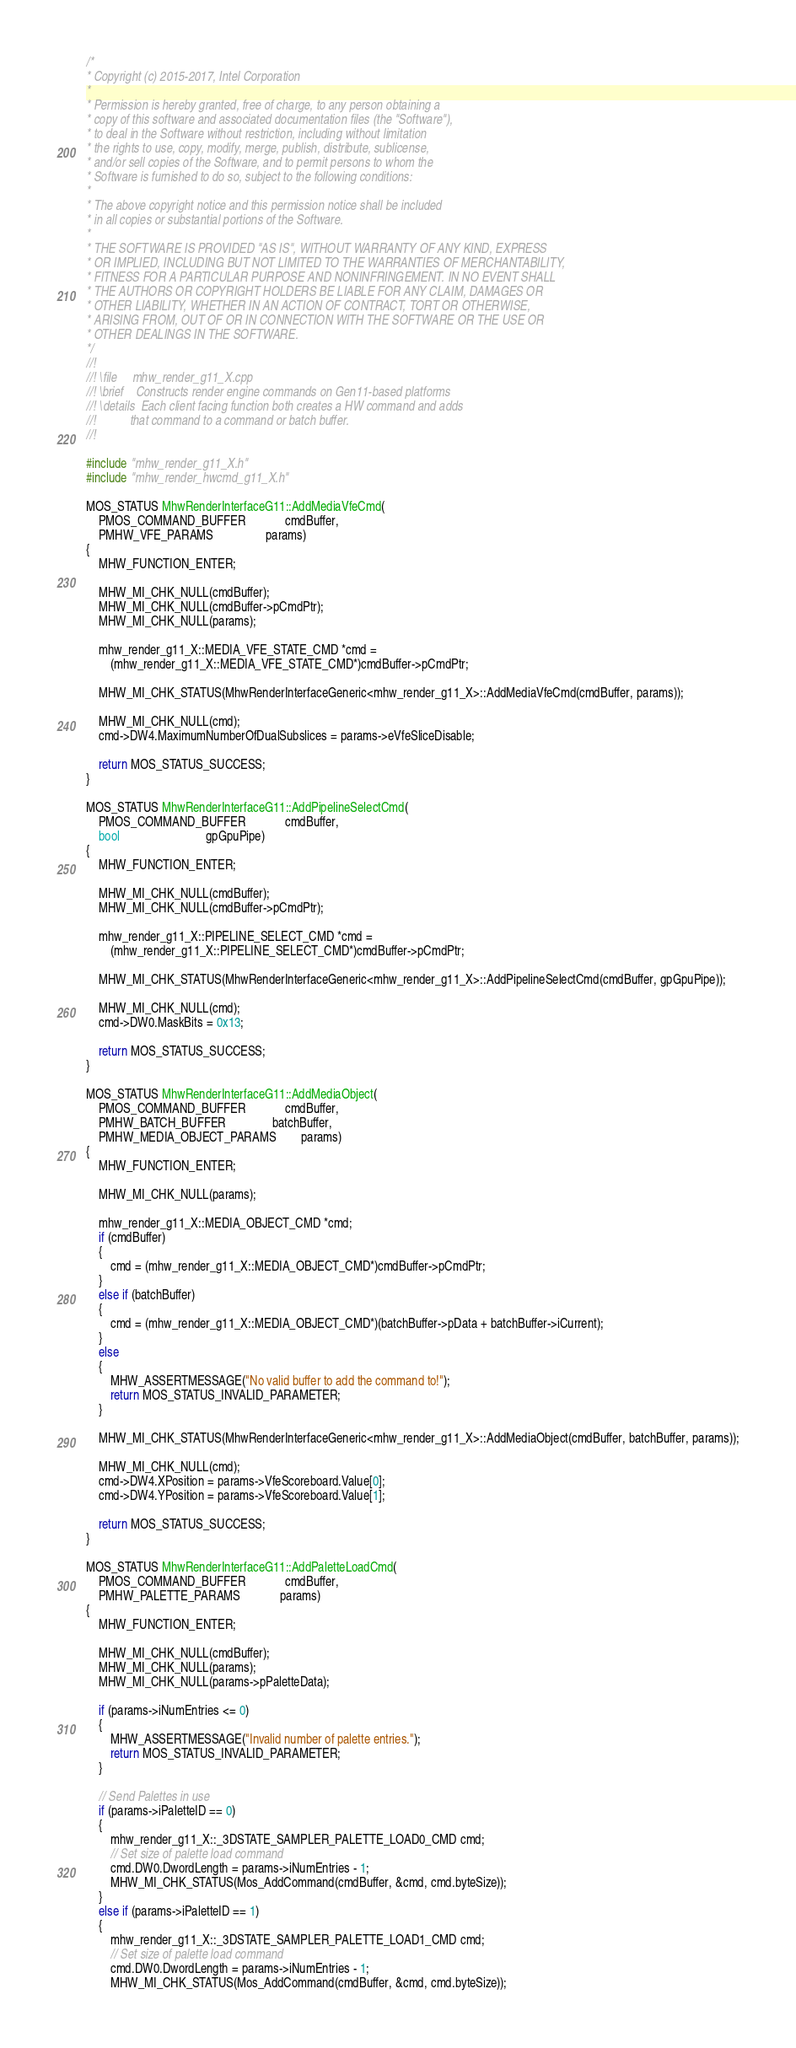<code> <loc_0><loc_0><loc_500><loc_500><_C++_>/*
* Copyright (c) 2015-2017, Intel Corporation
*
* Permission is hereby granted, free of charge, to any person obtaining a
* copy of this software and associated documentation files (the "Software"),
* to deal in the Software without restriction, including without limitation
* the rights to use, copy, modify, merge, publish, distribute, sublicense,
* and/or sell copies of the Software, and to permit persons to whom the
* Software is furnished to do so, subject to the following conditions:
*
* The above copyright notice and this permission notice shall be included
* in all copies or substantial portions of the Software.
*
* THE SOFTWARE IS PROVIDED "AS IS", WITHOUT WARRANTY OF ANY KIND, EXPRESS
* OR IMPLIED, INCLUDING BUT NOT LIMITED TO THE WARRANTIES OF MERCHANTABILITY,
* FITNESS FOR A PARTICULAR PURPOSE AND NONINFRINGEMENT. IN NO EVENT SHALL
* THE AUTHORS OR COPYRIGHT HOLDERS BE LIABLE FOR ANY CLAIM, DAMAGES OR
* OTHER LIABILITY, WHETHER IN AN ACTION OF CONTRACT, TORT OR OTHERWISE,
* ARISING FROM, OUT OF OR IN CONNECTION WITH THE SOFTWARE OR THE USE OR
* OTHER DEALINGS IN THE SOFTWARE.
*/
//!
//! \file     mhw_render_g11_X.cpp
//! \brief    Constructs render engine commands on Gen11-based platforms
//! \details  Each client facing function both creates a HW command and adds
//!           that command to a command or batch buffer.
//!

#include "mhw_render_g11_X.h"
#include "mhw_render_hwcmd_g11_X.h"

MOS_STATUS MhwRenderInterfaceG11::AddMediaVfeCmd(
    PMOS_COMMAND_BUFFER             cmdBuffer,
    PMHW_VFE_PARAMS                 params)
{
    MHW_FUNCTION_ENTER;

    MHW_MI_CHK_NULL(cmdBuffer);
    MHW_MI_CHK_NULL(cmdBuffer->pCmdPtr);
    MHW_MI_CHK_NULL(params);

    mhw_render_g11_X::MEDIA_VFE_STATE_CMD *cmd =
        (mhw_render_g11_X::MEDIA_VFE_STATE_CMD*)cmdBuffer->pCmdPtr;
    
    MHW_MI_CHK_STATUS(MhwRenderInterfaceGeneric<mhw_render_g11_X>::AddMediaVfeCmd(cmdBuffer, params));

    MHW_MI_CHK_NULL(cmd);
    cmd->DW4.MaximumNumberOfDualSubslices = params->eVfeSliceDisable;

    return MOS_STATUS_SUCCESS;
}

MOS_STATUS MhwRenderInterfaceG11::AddPipelineSelectCmd(
    PMOS_COMMAND_BUFFER             cmdBuffer,
    bool                            gpGpuPipe)
{
    MHW_FUNCTION_ENTER;

    MHW_MI_CHK_NULL(cmdBuffer);
    MHW_MI_CHK_NULL(cmdBuffer->pCmdPtr);

    mhw_render_g11_X::PIPELINE_SELECT_CMD *cmd =
        (mhw_render_g11_X::PIPELINE_SELECT_CMD*)cmdBuffer->pCmdPtr;

    MHW_MI_CHK_STATUS(MhwRenderInterfaceGeneric<mhw_render_g11_X>::AddPipelineSelectCmd(cmdBuffer, gpGpuPipe));

    MHW_MI_CHK_NULL(cmd);
    cmd->DW0.MaskBits = 0x13;

    return MOS_STATUS_SUCCESS;
}

MOS_STATUS MhwRenderInterfaceG11::AddMediaObject(
    PMOS_COMMAND_BUFFER             cmdBuffer,
    PMHW_BATCH_BUFFER               batchBuffer,
    PMHW_MEDIA_OBJECT_PARAMS        params)
{
    MHW_FUNCTION_ENTER;

    MHW_MI_CHK_NULL(params);

    mhw_render_g11_X::MEDIA_OBJECT_CMD *cmd;
    if (cmdBuffer)
    {
        cmd = (mhw_render_g11_X::MEDIA_OBJECT_CMD*)cmdBuffer->pCmdPtr;
    }
    else if (batchBuffer)
    {
        cmd = (mhw_render_g11_X::MEDIA_OBJECT_CMD*)(batchBuffer->pData + batchBuffer->iCurrent);
    }
    else
    {
        MHW_ASSERTMESSAGE("No valid buffer to add the command to!");
        return MOS_STATUS_INVALID_PARAMETER;
    }

    MHW_MI_CHK_STATUS(MhwRenderInterfaceGeneric<mhw_render_g11_X>::AddMediaObject(cmdBuffer, batchBuffer, params));

    MHW_MI_CHK_NULL(cmd);
    cmd->DW4.XPosition = params->VfeScoreboard.Value[0];
    cmd->DW4.YPosition = params->VfeScoreboard.Value[1];

    return MOS_STATUS_SUCCESS;
}

MOS_STATUS MhwRenderInterfaceG11::AddPaletteLoadCmd(
    PMOS_COMMAND_BUFFER             cmdBuffer,
    PMHW_PALETTE_PARAMS             params)
{
    MHW_FUNCTION_ENTER;

    MHW_MI_CHK_NULL(cmdBuffer);
    MHW_MI_CHK_NULL(params);
    MHW_MI_CHK_NULL(params->pPaletteData);

    if (params->iNumEntries <= 0)
    {
        MHW_ASSERTMESSAGE("Invalid number of palette entries.");
        return MOS_STATUS_INVALID_PARAMETER;
    }

    // Send Palettes in use
    if (params->iPaletteID == 0)
    {
        mhw_render_g11_X::_3DSTATE_SAMPLER_PALETTE_LOAD0_CMD cmd;
        // Set size of palette load command
        cmd.DW0.DwordLength = params->iNumEntries - 1;
        MHW_MI_CHK_STATUS(Mos_AddCommand(cmdBuffer, &cmd, cmd.byteSize));
    }
    else if (params->iPaletteID == 1)
    {
        mhw_render_g11_X::_3DSTATE_SAMPLER_PALETTE_LOAD1_CMD cmd;
        // Set size of palette load command
        cmd.DW0.DwordLength = params->iNumEntries - 1;
        MHW_MI_CHK_STATUS(Mos_AddCommand(cmdBuffer, &cmd, cmd.byteSize));</code> 